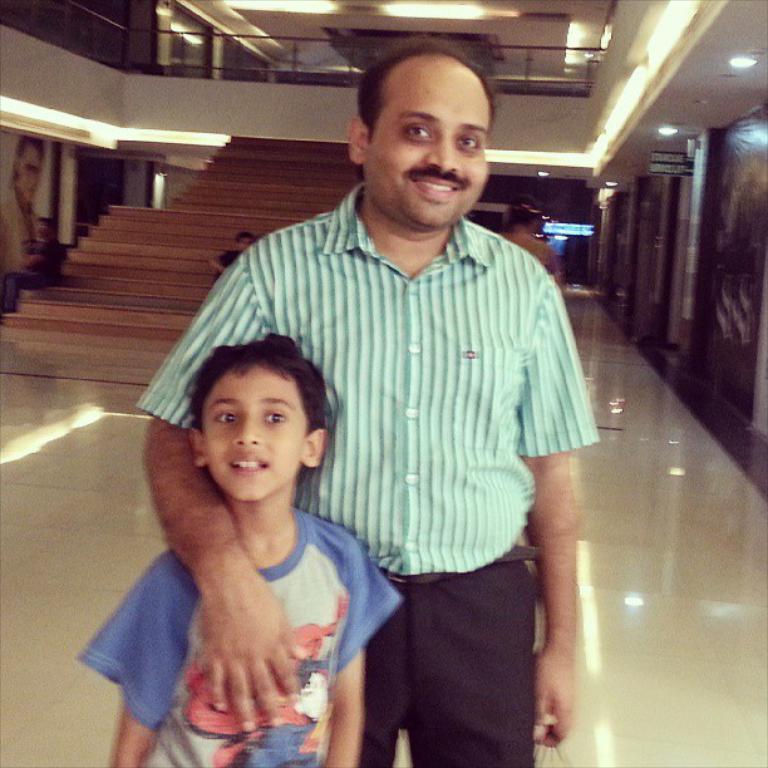Can you describe this image briefly? There are two persons standing on the ground and in the background we can see a wall,lights. 